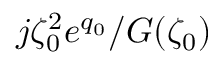<formula> <loc_0><loc_0><loc_500><loc_500>j \zeta _ { 0 } ^ { 2 } e ^ { q _ { 0 } } / G ( \zeta _ { 0 } )</formula> 